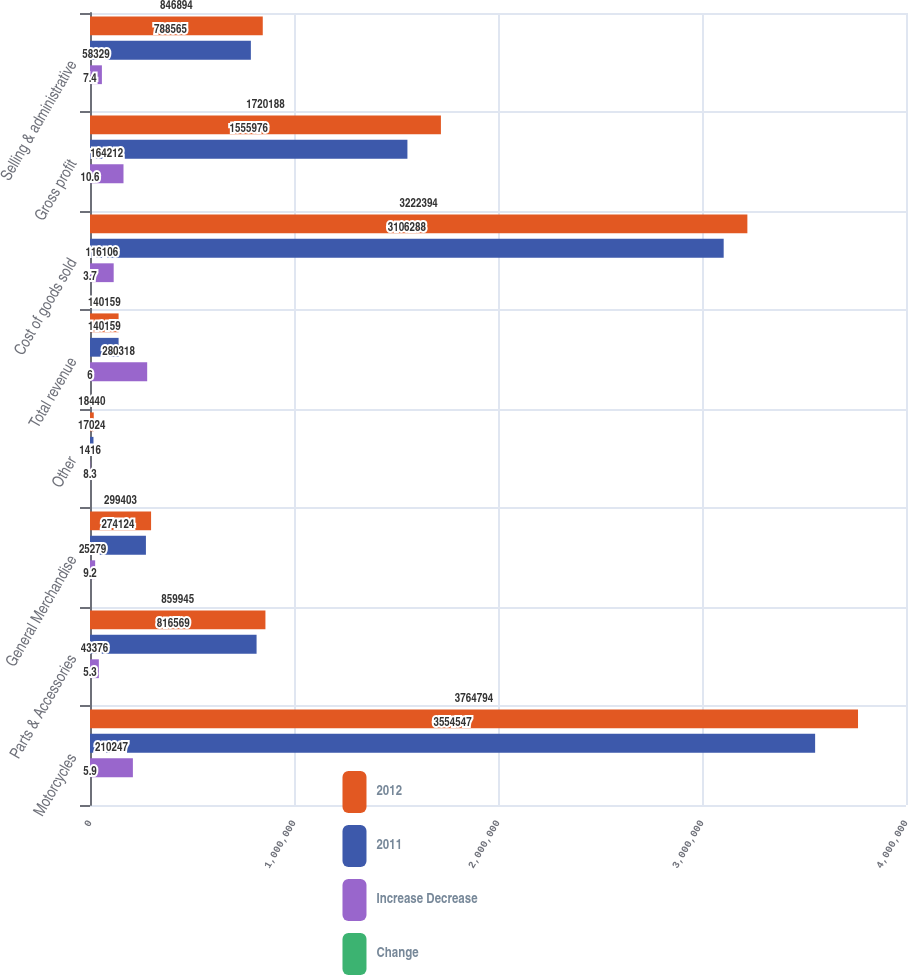Convert chart. <chart><loc_0><loc_0><loc_500><loc_500><stacked_bar_chart><ecel><fcel>Motorcycles<fcel>Parts & Accessories<fcel>General Merchandise<fcel>Other<fcel>Total revenue<fcel>Cost of goods sold<fcel>Gross profit<fcel>Selling & administrative<nl><fcel>2012<fcel>3.76479e+06<fcel>859945<fcel>299403<fcel>18440<fcel>140159<fcel>3.22239e+06<fcel>1.72019e+06<fcel>846894<nl><fcel>2011<fcel>3.55455e+06<fcel>816569<fcel>274124<fcel>17024<fcel>140159<fcel>3.10629e+06<fcel>1.55598e+06<fcel>788565<nl><fcel>Increase Decrease<fcel>210247<fcel>43376<fcel>25279<fcel>1416<fcel>280318<fcel>116106<fcel>164212<fcel>58329<nl><fcel>Change<fcel>5.9<fcel>5.3<fcel>9.2<fcel>8.3<fcel>6<fcel>3.7<fcel>10.6<fcel>7.4<nl></chart> 